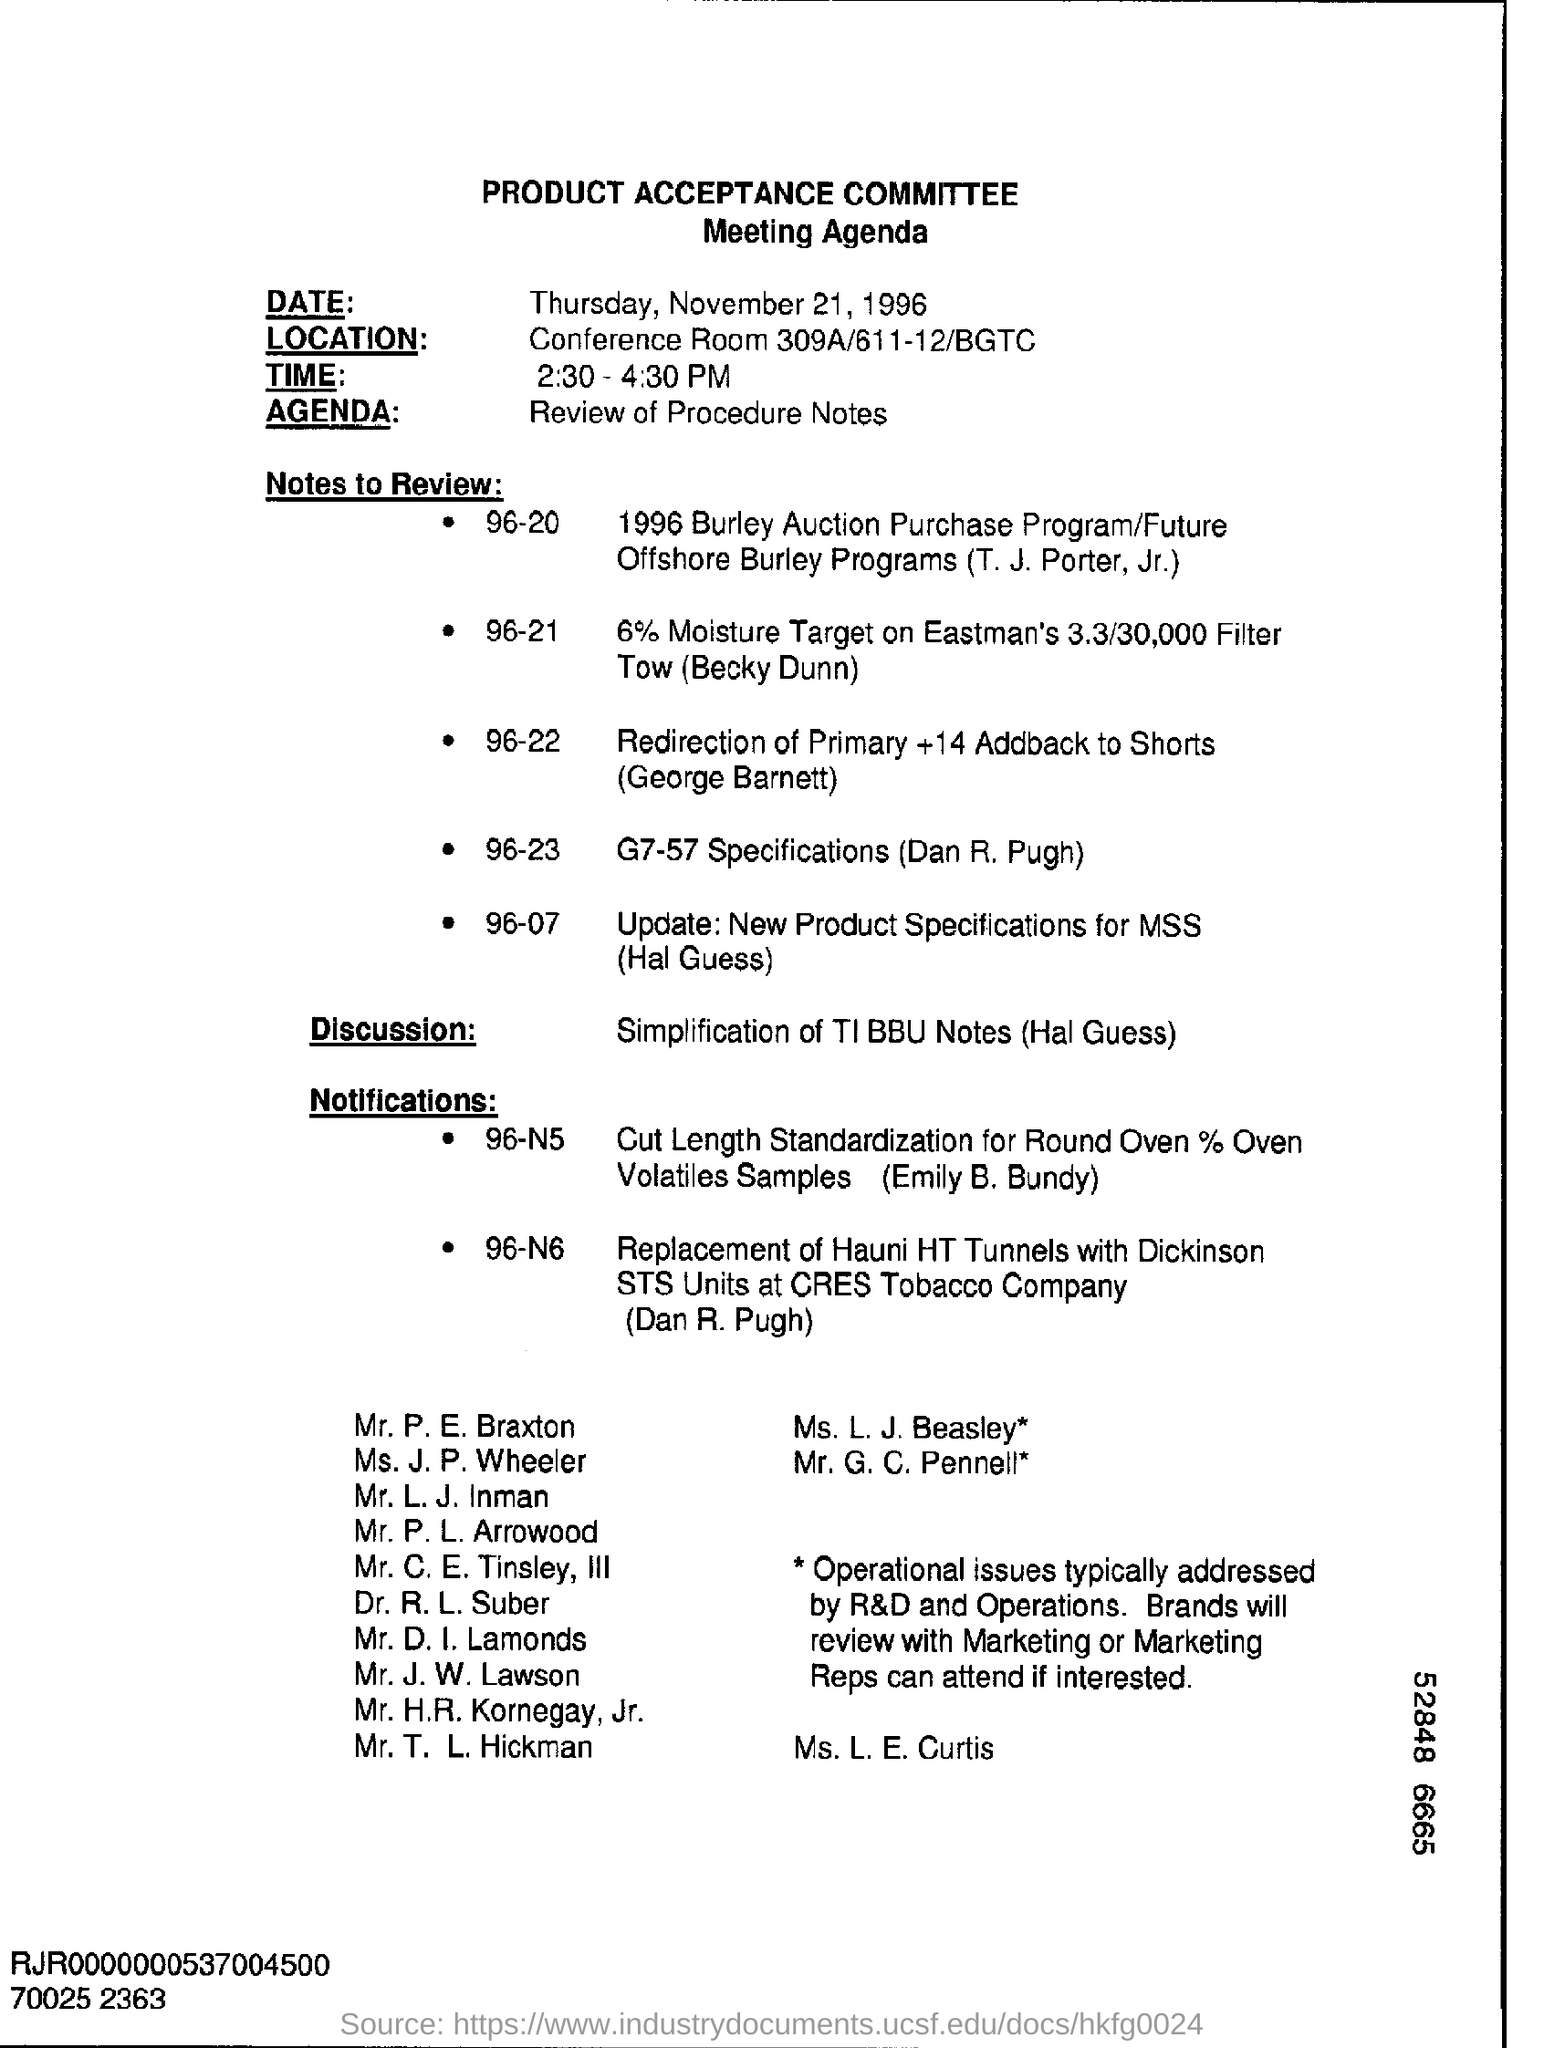What is written in the Agenda Field ?
Keep it short and to the point. Review of Procedure Notes. What is the date mentioned in the top of the document ?
Keep it short and to the point. Thursday, November 21, 1996. What is the agenda of this meeting?
Offer a terse response. Review of Procedure Notes. Where is the Location ?
Offer a very short reply. Conference Room 309A/611-12/BGTC. 